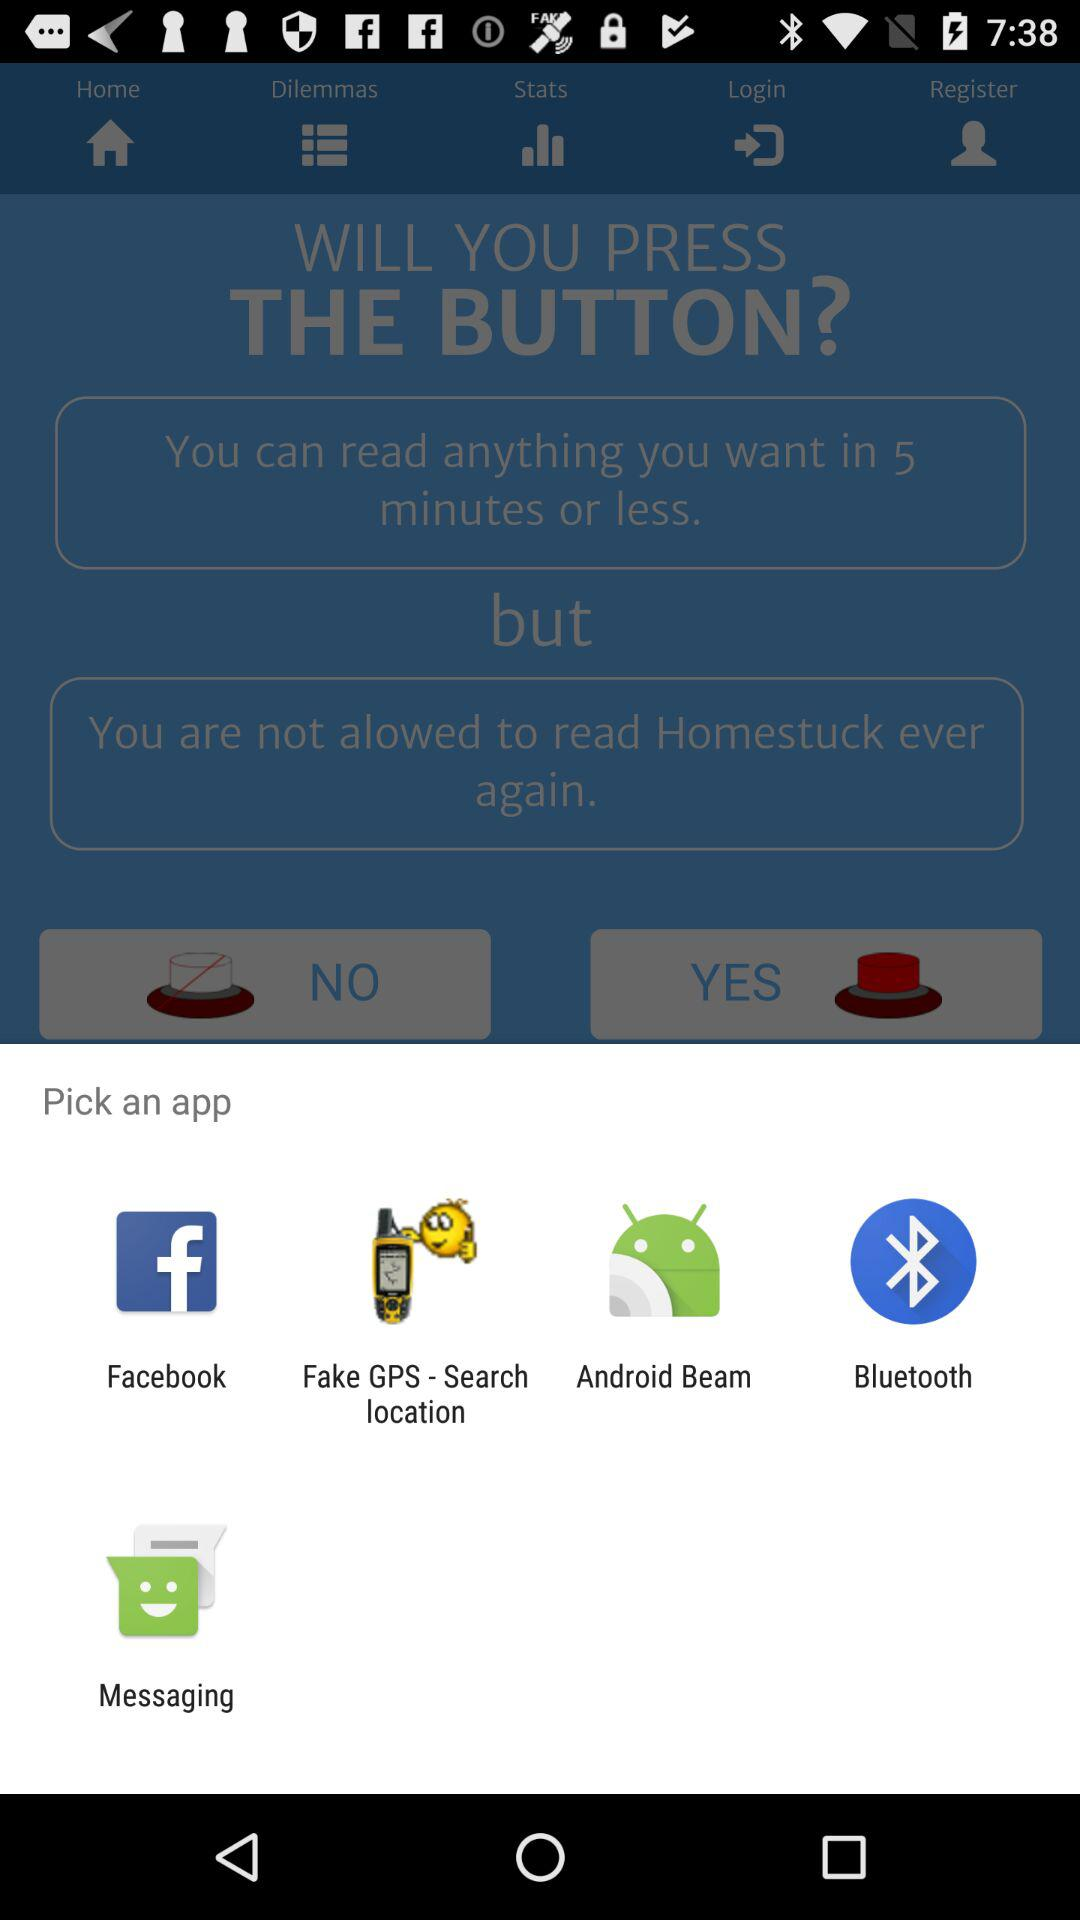What applications are available for sharing? The applications are "Facebook", "Fake GPS - Search location", "Android Beam", "Bluetooth", and "Messaging". 